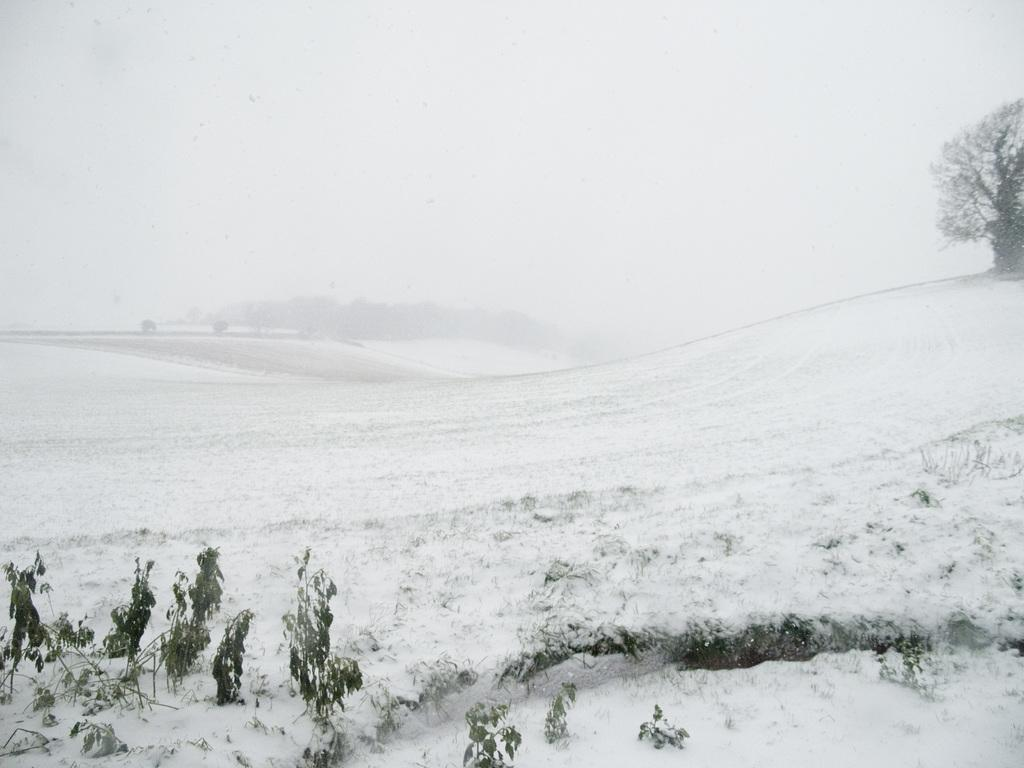What type of vegetation is present in the image? There is a tree and plants in the image. What is covering the plants in the image? Snow is covering the plants in the image. Can you describe the ground in the image? The ground at the bottom of the image is covered in snow. What type of work is the kitty doing in the image? There is no kitty present in the image, so it cannot be determined what type of work it might be doing. 